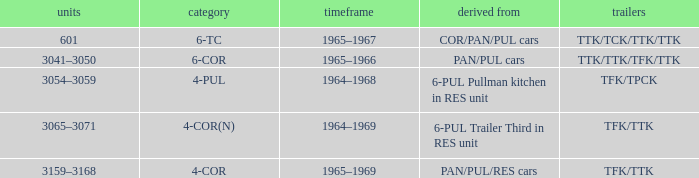Name the formed that has type of 4-cor PAN/PUL/RES cars. 